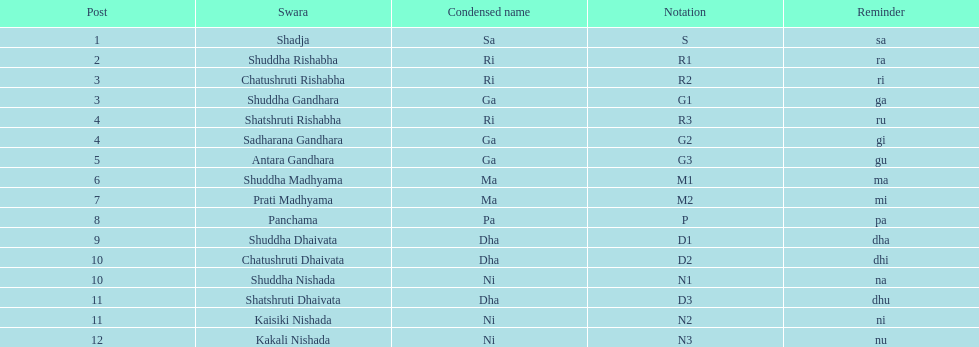How many swaras do not have dhaivata in their name? 13. 